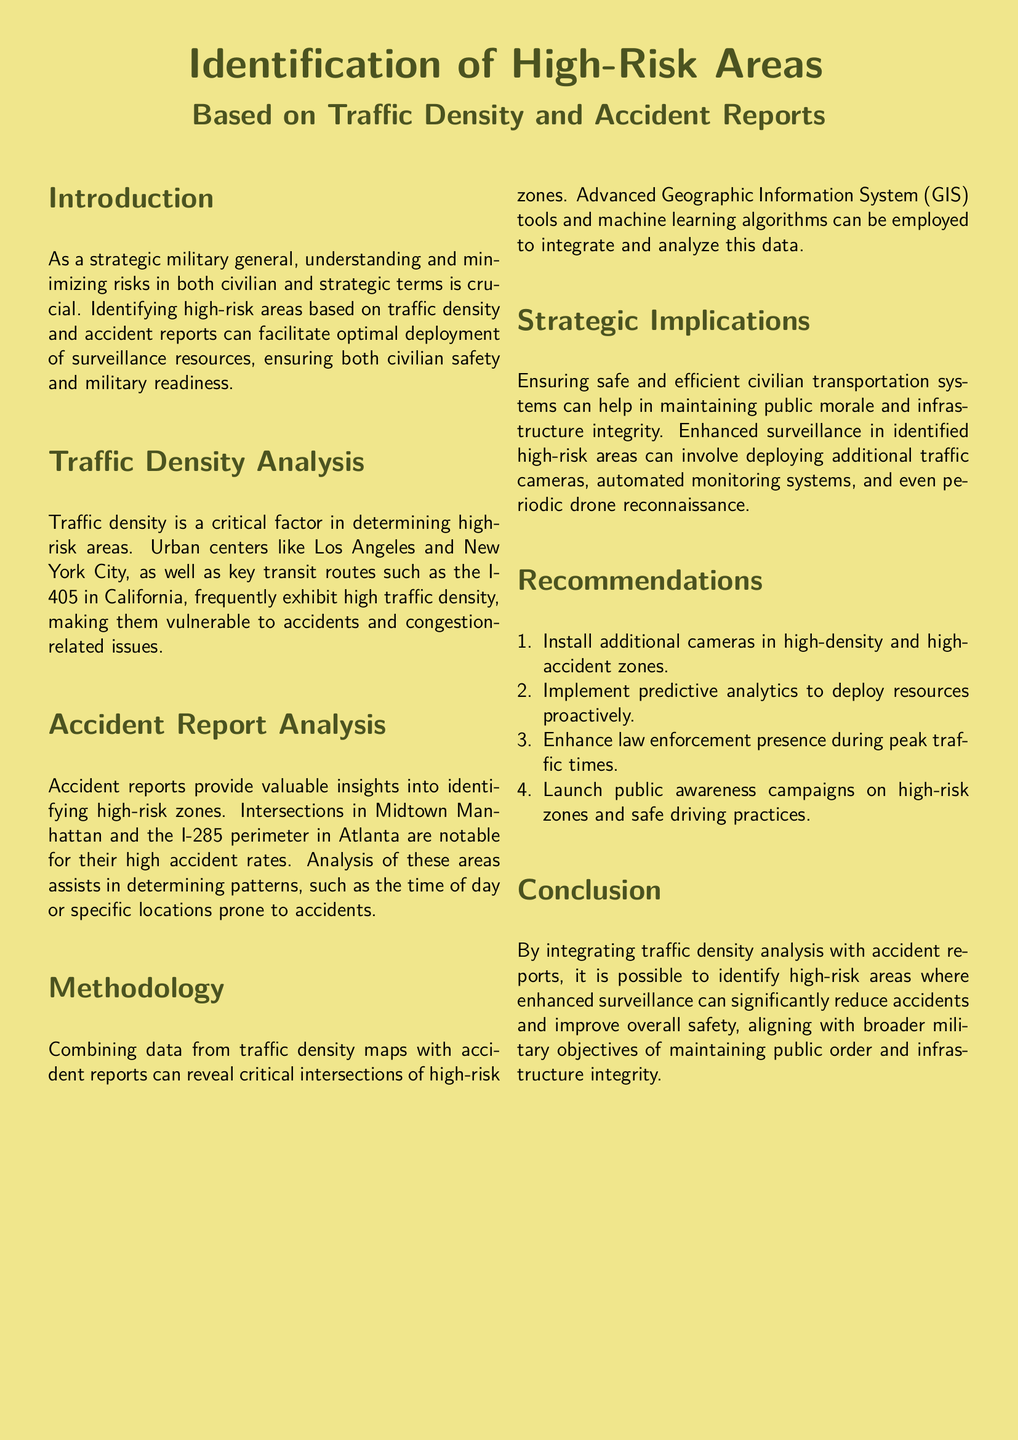What are two urban centers identified as high traffic density areas? The document specifically mentions urban centers like Los Angeles and New York City as high traffic density areas.
Answer: Los Angeles, New York City Which key transit route is highlighted in the report? The key transit route mentioned in the report is the I-405 in California, identified for its high traffic density.
Answer: I-405 What methodology is suggested for analyzing traffic density and accident reports? The report indicates using advanced Geographic Information System (GIS) tools and machine learning algorithms to combine and analyze traffic density and accident data.
Answer: GIS tools and machine learning algorithms What does the report suggest for public safety improvement in high-risk areas? The recommendations include installing additional cameras in high-density and high-accident zones to enhance surveillance and public safety.
Answer: Install additional cameras Which time of day is noted as relevant for accident patterns? The document states that there are specific patterns related to the time of day in areas prone to accidents, indicating there are peak times to monitor.
Answer: Time of day 